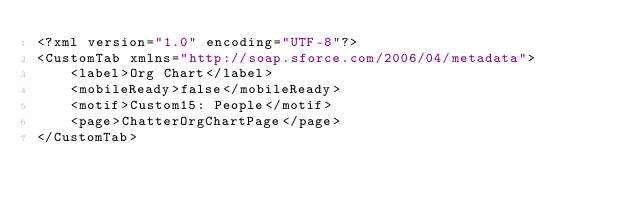<code> <loc_0><loc_0><loc_500><loc_500><_SQL_><?xml version="1.0" encoding="UTF-8"?>
<CustomTab xmlns="http://soap.sforce.com/2006/04/metadata">
    <label>Org Chart</label>
    <mobileReady>false</mobileReady>
    <motif>Custom15: People</motif>
    <page>ChatterOrgChartPage</page>
</CustomTab>
</code> 